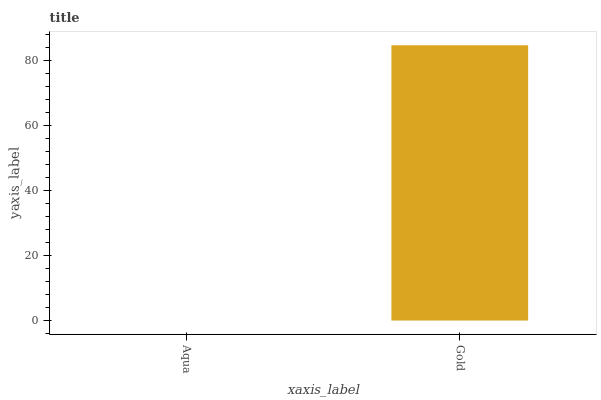Is Aqua the minimum?
Answer yes or no. Yes. Is Gold the maximum?
Answer yes or no. Yes. Is Gold the minimum?
Answer yes or no. No. Is Gold greater than Aqua?
Answer yes or no. Yes. Is Aqua less than Gold?
Answer yes or no. Yes. Is Aqua greater than Gold?
Answer yes or no. No. Is Gold less than Aqua?
Answer yes or no. No. Is Gold the high median?
Answer yes or no. Yes. Is Aqua the low median?
Answer yes or no. Yes. Is Aqua the high median?
Answer yes or no. No. Is Gold the low median?
Answer yes or no. No. 